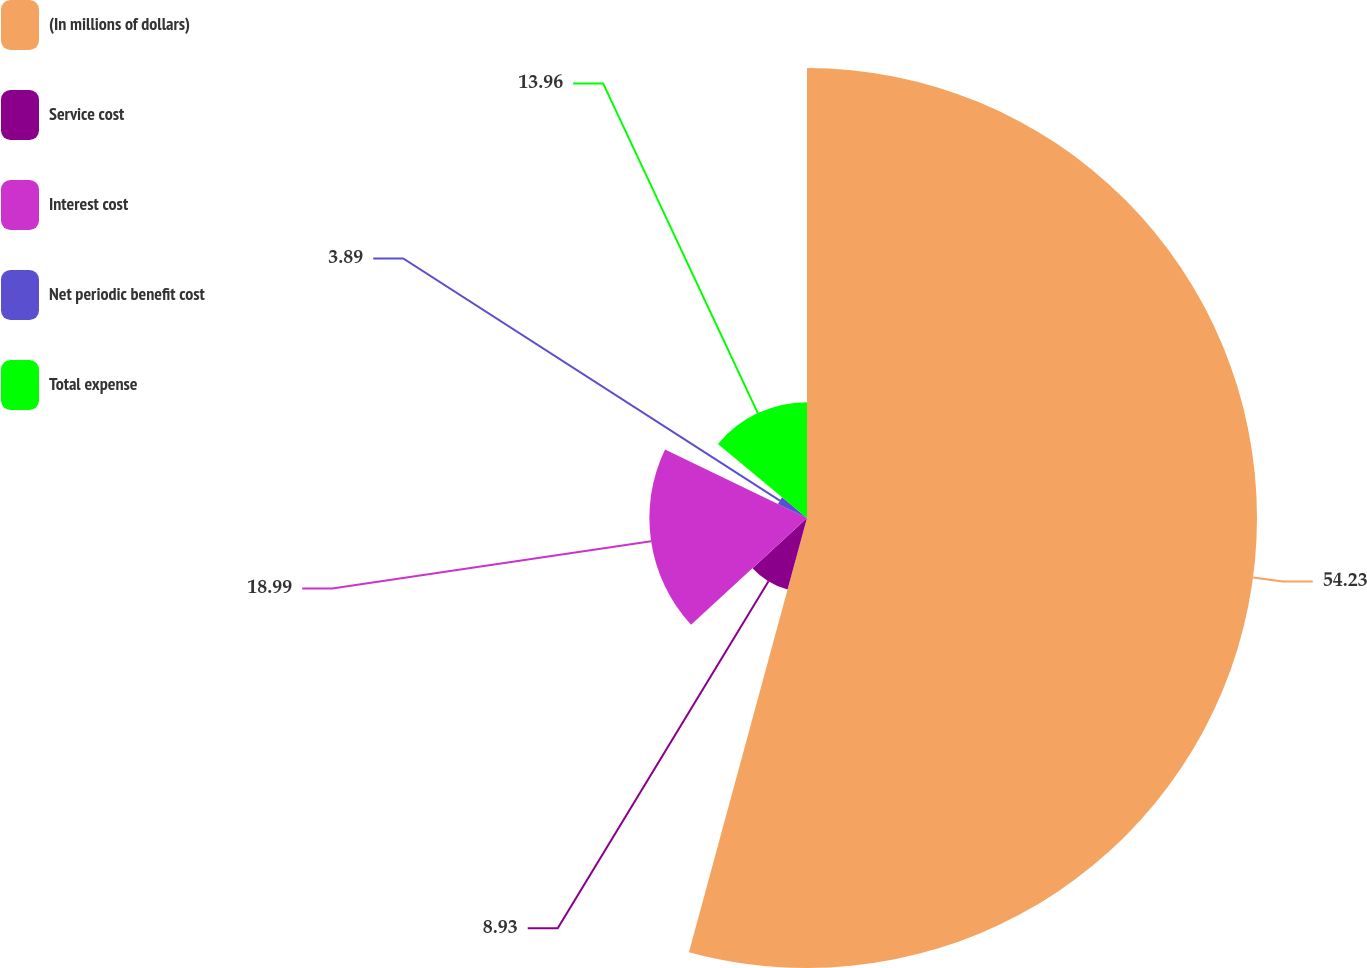Convert chart. <chart><loc_0><loc_0><loc_500><loc_500><pie_chart><fcel>(In millions of dollars)<fcel>Service cost<fcel>Interest cost<fcel>Net periodic benefit cost<fcel>Total expense<nl><fcel>54.22%<fcel>8.93%<fcel>18.99%<fcel>3.89%<fcel>13.96%<nl></chart> 